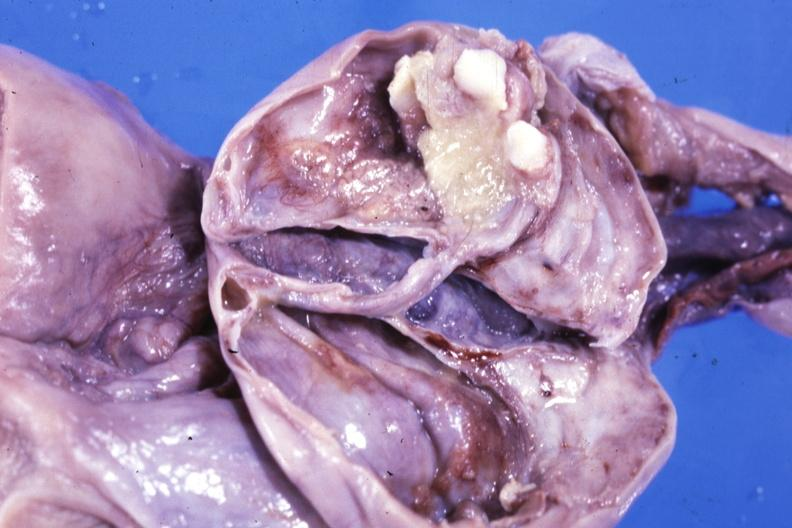how many teeth does this image show fixed tissue opened ovarian cyst with two or?
Answer the question using a single word or phrase. Three 